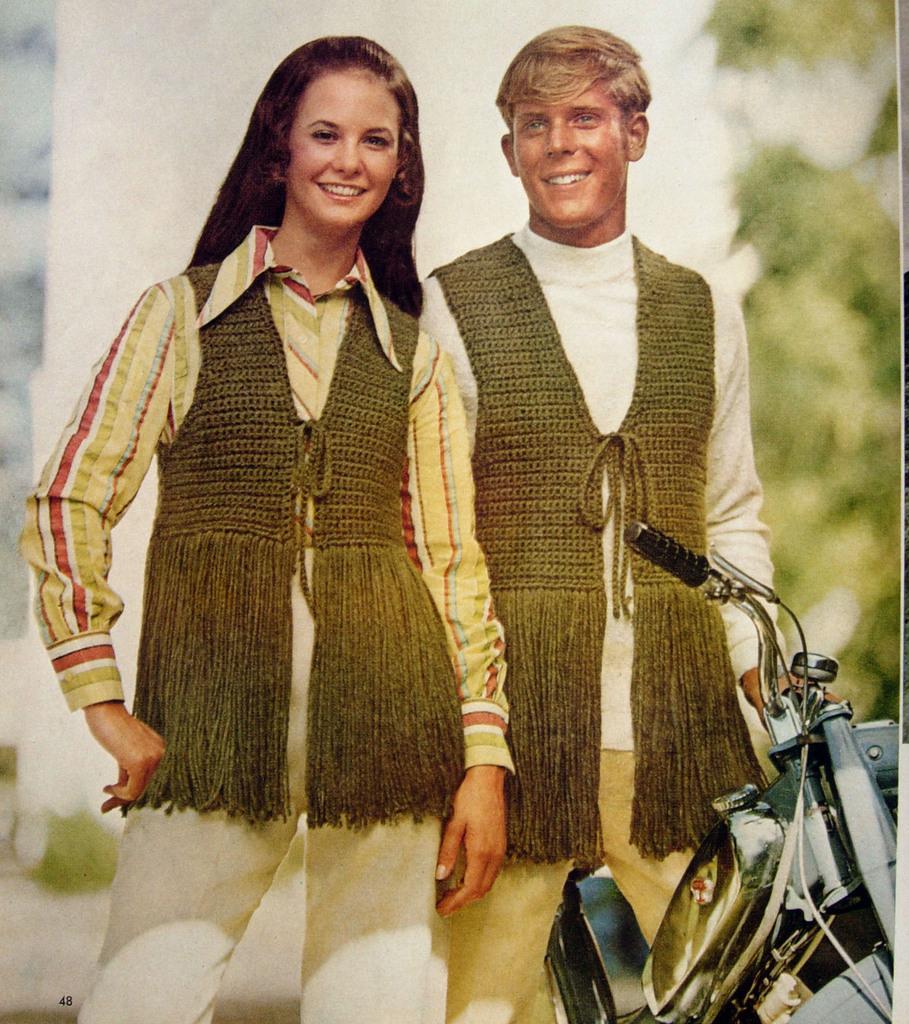Describe this image in one or two sentences. This image consists of a man and a woman. They are wearing same coats. There is a bike at the bottom. There is a tree on the right side. 